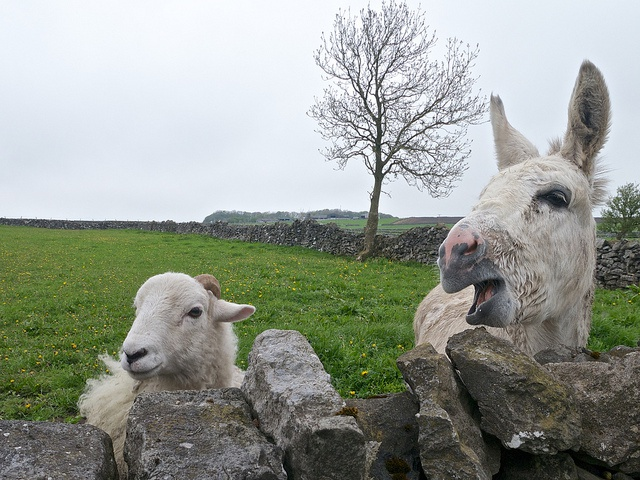Describe the objects in this image and their specific colors. I can see horse in white, darkgray, gray, lightgray, and black tones and sheep in white, darkgray, gray, and lightgray tones in this image. 